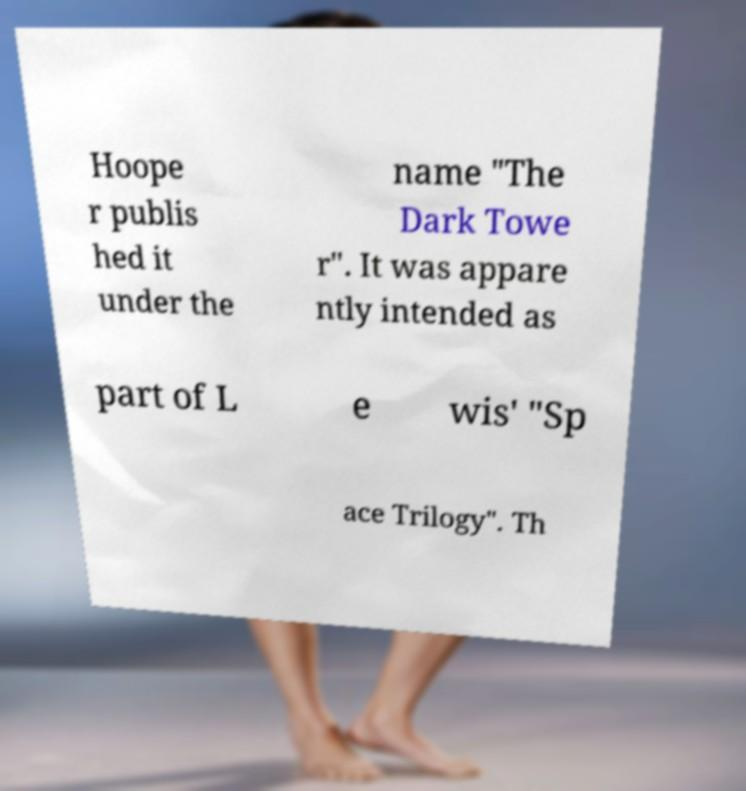What messages or text are displayed in this image? I need them in a readable, typed format. Hoope r publis hed it under the name "The Dark Towe r". It was appare ntly intended as part of L e wis' "Sp ace Trilogy". Th 